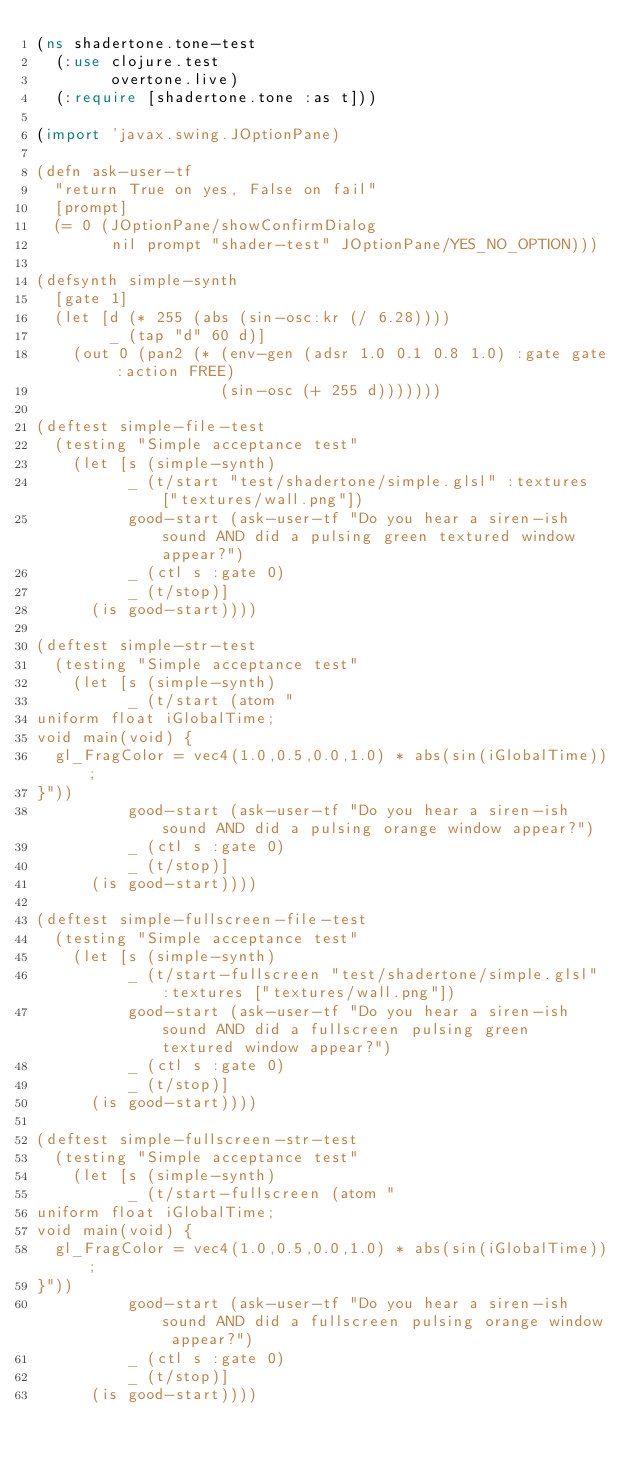Convert code to text. <code><loc_0><loc_0><loc_500><loc_500><_Clojure_>(ns shadertone.tone-test
  (:use clojure.test
        overtone.live)
  (:require [shadertone.tone :as t]))

(import 'javax.swing.JOptionPane)

(defn ask-user-tf
  "return True on yes, False on fail"
  [prompt]
  (= 0 (JOptionPane/showConfirmDialog
        nil prompt "shader-test" JOptionPane/YES_NO_OPTION)))

(defsynth simple-synth
  [gate 1]
  (let [d (* 255 (abs (sin-osc:kr (/ 6.28))))
        _ (tap "d" 60 d)]
    (out 0 (pan2 (* (env-gen (adsr 1.0 0.1 0.8 1.0) :gate gate :action FREE)
                    (sin-osc (+ 255 d)))))))

(deftest simple-file-test
  (testing "Simple acceptance test"
    (let [s (simple-synth)
          _ (t/start "test/shadertone/simple.glsl" :textures ["textures/wall.png"])
          good-start (ask-user-tf "Do you hear a siren-ish sound AND did a pulsing green textured window appear?")
          _ (ctl s :gate 0)
          _ (t/stop)]
      (is good-start))))

(deftest simple-str-test
  (testing "Simple acceptance test"
    (let [s (simple-synth)
          _ (t/start (atom "
uniform float iGlobalTime;
void main(void) {
  gl_FragColor = vec4(1.0,0.5,0.0,1.0) * abs(sin(iGlobalTime));
}"))
          good-start (ask-user-tf "Do you hear a siren-ish sound AND did a pulsing orange window appear?")
          _ (ctl s :gate 0)
          _ (t/stop)]
      (is good-start))))

(deftest simple-fullscreen-file-test
  (testing "Simple acceptance test"
    (let [s (simple-synth)
          _ (t/start-fullscreen "test/shadertone/simple.glsl" :textures ["textures/wall.png"])
          good-start (ask-user-tf "Do you hear a siren-ish sound AND did a fullscreen pulsing green textured window appear?")
          _ (ctl s :gate 0)
          _ (t/stop)]
      (is good-start))))

(deftest simple-fullscreen-str-test
  (testing "Simple acceptance test"
    (let [s (simple-synth)
          _ (t/start-fullscreen (atom "
uniform float iGlobalTime;
void main(void) {
  gl_FragColor = vec4(1.0,0.5,0.0,1.0) * abs(sin(iGlobalTime));
}"))
          good-start (ask-user-tf "Do you hear a siren-ish sound AND did a fullscreen pulsing orange window appear?")
          _ (ctl s :gate 0)
          _ (t/stop)]
      (is good-start))))
</code> 